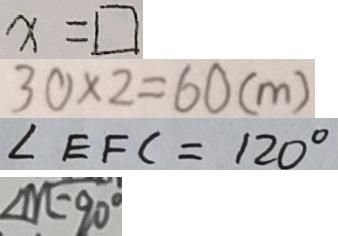Convert formula to latex. <formula><loc_0><loc_0><loc_500><loc_500>x = \square 
 3 0 \times 2 = 6 0 ( m ) 
 \angle E F C = 1 2 0 ^ { \circ } 
 \angle m = 9 0 ^ { \circ }</formula> 